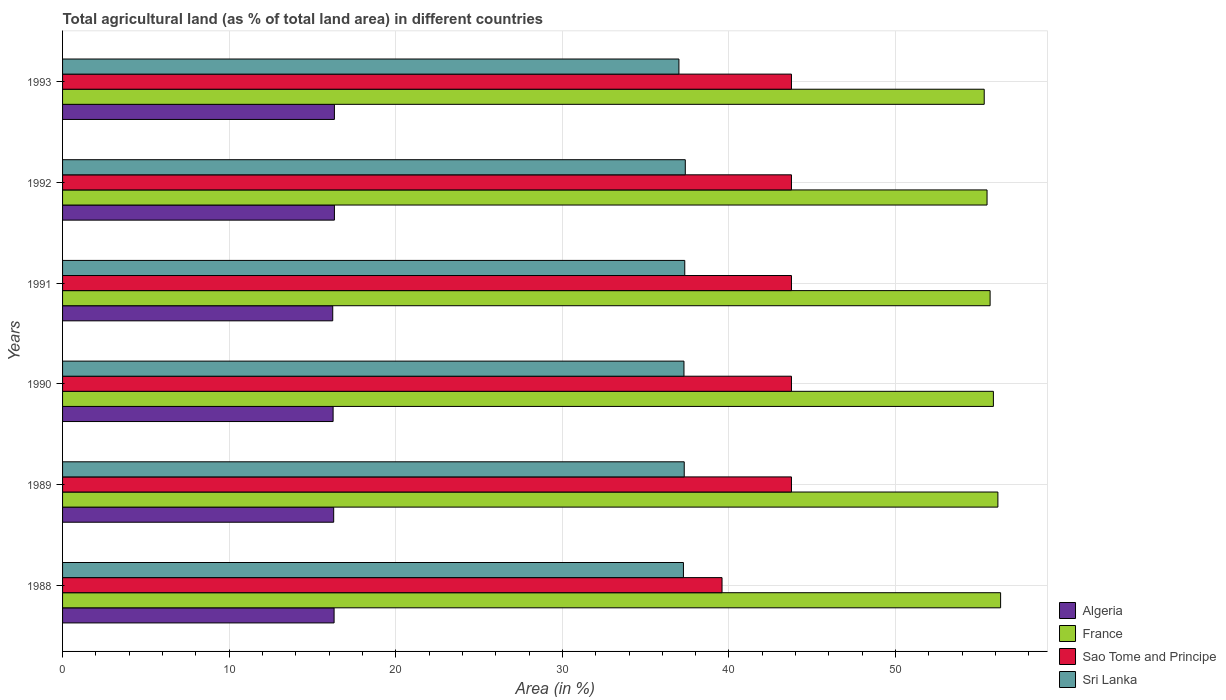How many groups of bars are there?
Offer a very short reply. 6. Are the number of bars on each tick of the Y-axis equal?
Your answer should be compact. Yes. How many bars are there on the 2nd tick from the top?
Offer a very short reply. 4. How many bars are there on the 5th tick from the bottom?
Your answer should be very brief. 4. What is the label of the 6th group of bars from the top?
Provide a succinct answer. 1988. In how many cases, is the number of bars for a given year not equal to the number of legend labels?
Provide a succinct answer. 0. What is the percentage of agricultural land in Algeria in 1989?
Offer a very short reply. 16.27. Across all years, what is the maximum percentage of agricultural land in Sao Tome and Principe?
Provide a succinct answer. 43.75. Across all years, what is the minimum percentage of agricultural land in France?
Ensure brevity in your answer.  55.32. In which year was the percentage of agricultural land in Algeria maximum?
Make the answer very short. 1992. What is the total percentage of agricultural land in Sri Lanka in the graph?
Your response must be concise. 223.6. What is the difference between the percentage of agricultural land in Sao Tome and Principe in 1993 and the percentage of agricultural land in Sri Lanka in 1988?
Provide a short and direct response. 6.48. What is the average percentage of agricultural land in Sao Tome and Principe per year?
Offer a terse response. 43.06. In the year 1991, what is the difference between the percentage of agricultural land in Algeria and percentage of agricultural land in France?
Offer a very short reply. -39.46. What is the ratio of the percentage of agricultural land in Algeria in 1990 to that in 1991?
Your response must be concise. 1. What is the difference between the highest and the second highest percentage of agricultural land in Sri Lanka?
Your answer should be very brief. 0.03. What is the difference between the highest and the lowest percentage of agricultural land in Sao Tome and Principe?
Offer a terse response. 4.17. In how many years, is the percentage of agricultural land in France greater than the average percentage of agricultural land in France taken over all years?
Offer a very short reply. 3. Is the sum of the percentage of agricultural land in Algeria in 1989 and 1991 greater than the maximum percentage of agricultural land in Sri Lanka across all years?
Provide a succinct answer. No. Is it the case that in every year, the sum of the percentage of agricultural land in Sao Tome and Principe and percentage of agricultural land in France is greater than the sum of percentage of agricultural land in Sri Lanka and percentage of agricultural land in Algeria?
Give a very brief answer. No. What does the 4th bar from the top in 1990 represents?
Offer a very short reply. Algeria. What does the 3rd bar from the bottom in 1992 represents?
Your response must be concise. Sao Tome and Principe. Is it the case that in every year, the sum of the percentage of agricultural land in France and percentage of agricultural land in Sri Lanka is greater than the percentage of agricultural land in Algeria?
Give a very brief answer. Yes. Are the values on the major ticks of X-axis written in scientific E-notation?
Offer a very short reply. No. Does the graph contain any zero values?
Your response must be concise. No. How many legend labels are there?
Provide a short and direct response. 4. How are the legend labels stacked?
Ensure brevity in your answer.  Vertical. What is the title of the graph?
Ensure brevity in your answer.  Total agricultural land (as % of total land area) in different countries. What is the label or title of the X-axis?
Make the answer very short. Area (in %). What is the Area (in %) in Algeria in 1988?
Ensure brevity in your answer.  16.3. What is the Area (in %) of France in 1988?
Offer a very short reply. 56.3. What is the Area (in %) of Sao Tome and Principe in 1988?
Ensure brevity in your answer.  39.58. What is the Area (in %) of Sri Lanka in 1988?
Your answer should be very brief. 37.27. What is the Area (in %) in Algeria in 1989?
Your answer should be very brief. 16.27. What is the Area (in %) of France in 1989?
Your answer should be compact. 56.14. What is the Area (in %) in Sao Tome and Principe in 1989?
Make the answer very short. 43.75. What is the Area (in %) of Sri Lanka in 1989?
Keep it short and to the point. 37.31. What is the Area (in %) in Algeria in 1990?
Provide a short and direct response. 16.24. What is the Area (in %) of France in 1990?
Your answer should be very brief. 55.87. What is the Area (in %) of Sao Tome and Principe in 1990?
Your answer should be compact. 43.75. What is the Area (in %) in Sri Lanka in 1990?
Keep it short and to the point. 37.3. What is the Area (in %) in Algeria in 1991?
Offer a terse response. 16.22. What is the Area (in %) of France in 1991?
Keep it short and to the point. 55.67. What is the Area (in %) in Sao Tome and Principe in 1991?
Provide a succinct answer. 43.75. What is the Area (in %) in Sri Lanka in 1991?
Offer a very short reply. 37.35. What is the Area (in %) of Algeria in 1992?
Provide a short and direct response. 16.32. What is the Area (in %) of France in 1992?
Keep it short and to the point. 55.49. What is the Area (in %) in Sao Tome and Principe in 1992?
Offer a very short reply. 43.75. What is the Area (in %) in Sri Lanka in 1992?
Offer a very short reply. 37.38. What is the Area (in %) in Algeria in 1993?
Your answer should be very brief. 16.32. What is the Area (in %) of France in 1993?
Your answer should be compact. 55.32. What is the Area (in %) of Sao Tome and Principe in 1993?
Make the answer very short. 43.75. What is the Area (in %) of Sri Lanka in 1993?
Offer a terse response. 37. Across all years, what is the maximum Area (in %) in Algeria?
Offer a terse response. 16.32. Across all years, what is the maximum Area (in %) in France?
Give a very brief answer. 56.3. Across all years, what is the maximum Area (in %) of Sao Tome and Principe?
Your response must be concise. 43.75. Across all years, what is the maximum Area (in %) of Sri Lanka?
Provide a short and direct response. 37.38. Across all years, what is the minimum Area (in %) of Algeria?
Your answer should be very brief. 16.22. Across all years, what is the minimum Area (in %) of France?
Provide a short and direct response. 55.32. Across all years, what is the minimum Area (in %) of Sao Tome and Principe?
Your response must be concise. 39.58. Across all years, what is the minimum Area (in %) in Sri Lanka?
Your answer should be compact. 37. What is the total Area (in %) of Algeria in the graph?
Keep it short and to the point. 97.66. What is the total Area (in %) in France in the graph?
Your answer should be compact. 334.8. What is the total Area (in %) of Sao Tome and Principe in the graph?
Ensure brevity in your answer.  258.33. What is the total Area (in %) in Sri Lanka in the graph?
Your response must be concise. 223.6. What is the difference between the Area (in %) of Algeria in 1988 and that in 1989?
Ensure brevity in your answer.  0.02. What is the difference between the Area (in %) in France in 1988 and that in 1989?
Provide a succinct answer. 0.16. What is the difference between the Area (in %) in Sao Tome and Principe in 1988 and that in 1989?
Provide a succinct answer. -4.17. What is the difference between the Area (in %) in Sri Lanka in 1988 and that in 1989?
Offer a terse response. -0.05. What is the difference between the Area (in %) of Algeria in 1988 and that in 1990?
Give a very brief answer. 0.06. What is the difference between the Area (in %) in France in 1988 and that in 1990?
Offer a very short reply. 0.43. What is the difference between the Area (in %) in Sao Tome and Principe in 1988 and that in 1990?
Ensure brevity in your answer.  -4.17. What is the difference between the Area (in %) in Sri Lanka in 1988 and that in 1990?
Give a very brief answer. -0.03. What is the difference between the Area (in %) in Algeria in 1988 and that in 1991?
Make the answer very short. 0.08. What is the difference between the Area (in %) of France in 1988 and that in 1991?
Provide a succinct answer. 0.63. What is the difference between the Area (in %) in Sao Tome and Principe in 1988 and that in 1991?
Provide a succinct answer. -4.17. What is the difference between the Area (in %) of Sri Lanka in 1988 and that in 1991?
Your answer should be very brief. -0.08. What is the difference between the Area (in %) of Algeria in 1988 and that in 1992?
Your response must be concise. -0.02. What is the difference between the Area (in %) of France in 1988 and that in 1992?
Offer a very short reply. 0.81. What is the difference between the Area (in %) in Sao Tome and Principe in 1988 and that in 1992?
Offer a very short reply. -4.17. What is the difference between the Area (in %) of Sri Lanka in 1988 and that in 1992?
Ensure brevity in your answer.  -0.11. What is the difference between the Area (in %) in Algeria in 1988 and that in 1993?
Make the answer very short. -0.02. What is the difference between the Area (in %) in France in 1988 and that in 1993?
Provide a succinct answer. 0.98. What is the difference between the Area (in %) in Sao Tome and Principe in 1988 and that in 1993?
Give a very brief answer. -4.17. What is the difference between the Area (in %) of Sri Lanka in 1988 and that in 1993?
Make the answer very short. 0.27. What is the difference between the Area (in %) of Algeria in 1989 and that in 1990?
Ensure brevity in your answer.  0.04. What is the difference between the Area (in %) of France in 1989 and that in 1990?
Keep it short and to the point. 0.27. What is the difference between the Area (in %) in Sao Tome and Principe in 1989 and that in 1990?
Provide a short and direct response. 0. What is the difference between the Area (in %) of Sri Lanka in 1989 and that in 1990?
Your response must be concise. 0.02. What is the difference between the Area (in %) in Algeria in 1989 and that in 1991?
Make the answer very short. 0.06. What is the difference between the Area (in %) of France in 1989 and that in 1991?
Give a very brief answer. 0.47. What is the difference between the Area (in %) in Sao Tome and Principe in 1989 and that in 1991?
Provide a succinct answer. 0. What is the difference between the Area (in %) in Sri Lanka in 1989 and that in 1991?
Offer a terse response. -0.03. What is the difference between the Area (in %) in Algeria in 1989 and that in 1992?
Offer a terse response. -0.04. What is the difference between the Area (in %) of France in 1989 and that in 1992?
Make the answer very short. 0.65. What is the difference between the Area (in %) of Sao Tome and Principe in 1989 and that in 1992?
Ensure brevity in your answer.  0. What is the difference between the Area (in %) in Sri Lanka in 1989 and that in 1992?
Your answer should be compact. -0.06. What is the difference between the Area (in %) in Algeria in 1989 and that in 1993?
Make the answer very short. -0.04. What is the difference between the Area (in %) in France in 1989 and that in 1993?
Offer a very short reply. 0.82. What is the difference between the Area (in %) in Sri Lanka in 1989 and that in 1993?
Your answer should be very brief. 0.32. What is the difference between the Area (in %) of Algeria in 1990 and that in 1991?
Provide a succinct answer. 0.02. What is the difference between the Area (in %) of France in 1990 and that in 1991?
Give a very brief answer. 0.2. What is the difference between the Area (in %) in Sri Lanka in 1990 and that in 1991?
Provide a short and direct response. -0.05. What is the difference between the Area (in %) in Algeria in 1990 and that in 1992?
Your answer should be compact. -0.08. What is the difference between the Area (in %) of France in 1990 and that in 1992?
Make the answer very short. 0.38. What is the difference between the Area (in %) of Sao Tome and Principe in 1990 and that in 1992?
Your response must be concise. 0. What is the difference between the Area (in %) of Sri Lanka in 1990 and that in 1992?
Offer a very short reply. -0.08. What is the difference between the Area (in %) of Algeria in 1990 and that in 1993?
Give a very brief answer. -0.08. What is the difference between the Area (in %) in France in 1990 and that in 1993?
Give a very brief answer. 0.55. What is the difference between the Area (in %) of Sri Lanka in 1990 and that in 1993?
Your answer should be compact. 0.3. What is the difference between the Area (in %) in Algeria in 1991 and that in 1992?
Keep it short and to the point. -0.1. What is the difference between the Area (in %) of France in 1991 and that in 1992?
Offer a very short reply. 0.18. What is the difference between the Area (in %) of Sao Tome and Principe in 1991 and that in 1992?
Your answer should be compact. 0. What is the difference between the Area (in %) in Sri Lanka in 1991 and that in 1992?
Your answer should be compact. -0.03. What is the difference between the Area (in %) in Algeria in 1991 and that in 1993?
Provide a succinct answer. -0.1. What is the difference between the Area (in %) in France in 1991 and that in 1993?
Provide a succinct answer. 0.35. What is the difference between the Area (in %) of Sri Lanka in 1991 and that in 1993?
Make the answer very short. 0.35. What is the difference between the Area (in %) in Algeria in 1992 and that in 1993?
Offer a terse response. 0. What is the difference between the Area (in %) of France in 1992 and that in 1993?
Offer a very short reply. 0.17. What is the difference between the Area (in %) of Sri Lanka in 1992 and that in 1993?
Offer a very short reply. 0.38. What is the difference between the Area (in %) in Algeria in 1988 and the Area (in %) in France in 1989?
Provide a short and direct response. -39.84. What is the difference between the Area (in %) of Algeria in 1988 and the Area (in %) of Sao Tome and Principe in 1989?
Give a very brief answer. -27.45. What is the difference between the Area (in %) of Algeria in 1988 and the Area (in %) of Sri Lanka in 1989?
Your answer should be very brief. -21.02. What is the difference between the Area (in %) in France in 1988 and the Area (in %) in Sao Tome and Principe in 1989?
Your answer should be compact. 12.55. What is the difference between the Area (in %) of France in 1988 and the Area (in %) of Sri Lanka in 1989?
Provide a short and direct response. 18.99. What is the difference between the Area (in %) in Sao Tome and Principe in 1988 and the Area (in %) in Sri Lanka in 1989?
Ensure brevity in your answer.  2.27. What is the difference between the Area (in %) in Algeria in 1988 and the Area (in %) in France in 1990?
Ensure brevity in your answer.  -39.57. What is the difference between the Area (in %) in Algeria in 1988 and the Area (in %) in Sao Tome and Principe in 1990?
Your response must be concise. -27.45. What is the difference between the Area (in %) in Algeria in 1988 and the Area (in %) in Sri Lanka in 1990?
Your answer should be compact. -21. What is the difference between the Area (in %) of France in 1988 and the Area (in %) of Sao Tome and Principe in 1990?
Offer a very short reply. 12.55. What is the difference between the Area (in %) in France in 1988 and the Area (in %) in Sri Lanka in 1990?
Offer a terse response. 19. What is the difference between the Area (in %) of Sao Tome and Principe in 1988 and the Area (in %) of Sri Lanka in 1990?
Provide a succinct answer. 2.28. What is the difference between the Area (in %) of Algeria in 1988 and the Area (in %) of France in 1991?
Make the answer very short. -39.38. What is the difference between the Area (in %) of Algeria in 1988 and the Area (in %) of Sao Tome and Principe in 1991?
Offer a very short reply. -27.45. What is the difference between the Area (in %) in Algeria in 1988 and the Area (in %) in Sri Lanka in 1991?
Your answer should be very brief. -21.05. What is the difference between the Area (in %) in France in 1988 and the Area (in %) in Sao Tome and Principe in 1991?
Your response must be concise. 12.55. What is the difference between the Area (in %) in France in 1988 and the Area (in %) in Sri Lanka in 1991?
Your response must be concise. 18.96. What is the difference between the Area (in %) of Sao Tome and Principe in 1988 and the Area (in %) of Sri Lanka in 1991?
Ensure brevity in your answer.  2.24. What is the difference between the Area (in %) in Algeria in 1988 and the Area (in %) in France in 1992?
Your answer should be compact. -39.19. What is the difference between the Area (in %) of Algeria in 1988 and the Area (in %) of Sao Tome and Principe in 1992?
Your answer should be very brief. -27.45. What is the difference between the Area (in %) in Algeria in 1988 and the Area (in %) in Sri Lanka in 1992?
Ensure brevity in your answer.  -21.08. What is the difference between the Area (in %) in France in 1988 and the Area (in %) in Sao Tome and Principe in 1992?
Your answer should be very brief. 12.55. What is the difference between the Area (in %) of France in 1988 and the Area (in %) of Sri Lanka in 1992?
Offer a very short reply. 18.93. What is the difference between the Area (in %) of Sao Tome and Principe in 1988 and the Area (in %) of Sri Lanka in 1992?
Your response must be concise. 2.2. What is the difference between the Area (in %) of Algeria in 1988 and the Area (in %) of France in 1993?
Keep it short and to the point. -39.02. What is the difference between the Area (in %) in Algeria in 1988 and the Area (in %) in Sao Tome and Principe in 1993?
Offer a terse response. -27.45. What is the difference between the Area (in %) in Algeria in 1988 and the Area (in %) in Sri Lanka in 1993?
Your answer should be compact. -20.7. What is the difference between the Area (in %) in France in 1988 and the Area (in %) in Sao Tome and Principe in 1993?
Your response must be concise. 12.55. What is the difference between the Area (in %) in France in 1988 and the Area (in %) in Sri Lanka in 1993?
Ensure brevity in your answer.  19.31. What is the difference between the Area (in %) of Sao Tome and Principe in 1988 and the Area (in %) of Sri Lanka in 1993?
Your answer should be very brief. 2.59. What is the difference between the Area (in %) of Algeria in 1989 and the Area (in %) of France in 1990?
Provide a short and direct response. -39.6. What is the difference between the Area (in %) in Algeria in 1989 and the Area (in %) in Sao Tome and Principe in 1990?
Offer a very short reply. -27.48. What is the difference between the Area (in %) of Algeria in 1989 and the Area (in %) of Sri Lanka in 1990?
Keep it short and to the point. -21.02. What is the difference between the Area (in %) of France in 1989 and the Area (in %) of Sao Tome and Principe in 1990?
Make the answer very short. 12.39. What is the difference between the Area (in %) in France in 1989 and the Area (in %) in Sri Lanka in 1990?
Provide a short and direct response. 18.84. What is the difference between the Area (in %) in Sao Tome and Principe in 1989 and the Area (in %) in Sri Lanka in 1990?
Provide a succinct answer. 6.45. What is the difference between the Area (in %) in Algeria in 1989 and the Area (in %) in France in 1991?
Provide a short and direct response. -39.4. What is the difference between the Area (in %) of Algeria in 1989 and the Area (in %) of Sao Tome and Principe in 1991?
Offer a very short reply. -27.48. What is the difference between the Area (in %) in Algeria in 1989 and the Area (in %) in Sri Lanka in 1991?
Keep it short and to the point. -21.07. What is the difference between the Area (in %) of France in 1989 and the Area (in %) of Sao Tome and Principe in 1991?
Your answer should be compact. 12.39. What is the difference between the Area (in %) in France in 1989 and the Area (in %) in Sri Lanka in 1991?
Offer a terse response. 18.79. What is the difference between the Area (in %) of Sao Tome and Principe in 1989 and the Area (in %) of Sri Lanka in 1991?
Your answer should be very brief. 6.4. What is the difference between the Area (in %) in Algeria in 1989 and the Area (in %) in France in 1992?
Make the answer very short. -39.22. What is the difference between the Area (in %) in Algeria in 1989 and the Area (in %) in Sao Tome and Principe in 1992?
Keep it short and to the point. -27.48. What is the difference between the Area (in %) of Algeria in 1989 and the Area (in %) of Sri Lanka in 1992?
Make the answer very short. -21.1. What is the difference between the Area (in %) in France in 1989 and the Area (in %) in Sao Tome and Principe in 1992?
Make the answer very short. 12.39. What is the difference between the Area (in %) in France in 1989 and the Area (in %) in Sri Lanka in 1992?
Your answer should be very brief. 18.76. What is the difference between the Area (in %) in Sao Tome and Principe in 1989 and the Area (in %) in Sri Lanka in 1992?
Keep it short and to the point. 6.37. What is the difference between the Area (in %) of Algeria in 1989 and the Area (in %) of France in 1993?
Keep it short and to the point. -39.05. What is the difference between the Area (in %) of Algeria in 1989 and the Area (in %) of Sao Tome and Principe in 1993?
Offer a terse response. -27.48. What is the difference between the Area (in %) of Algeria in 1989 and the Area (in %) of Sri Lanka in 1993?
Make the answer very short. -20.72. What is the difference between the Area (in %) in France in 1989 and the Area (in %) in Sao Tome and Principe in 1993?
Your response must be concise. 12.39. What is the difference between the Area (in %) in France in 1989 and the Area (in %) in Sri Lanka in 1993?
Your response must be concise. 19.15. What is the difference between the Area (in %) of Sao Tome and Principe in 1989 and the Area (in %) of Sri Lanka in 1993?
Give a very brief answer. 6.75. What is the difference between the Area (in %) in Algeria in 1990 and the Area (in %) in France in 1991?
Give a very brief answer. -39.43. What is the difference between the Area (in %) of Algeria in 1990 and the Area (in %) of Sao Tome and Principe in 1991?
Offer a very short reply. -27.51. What is the difference between the Area (in %) of Algeria in 1990 and the Area (in %) of Sri Lanka in 1991?
Your answer should be very brief. -21.11. What is the difference between the Area (in %) in France in 1990 and the Area (in %) in Sao Tome and Principe in 1991?
Keep it short and to the point. 12.12. What is the difference between the Area (in %) in France in 1990 and the Area (in %) in Sri Lanka in 1991?
Your answer should be very brief. 18.52. What is the difference between the Area (in %) in Sao Tome and Principe in 1990 and the Area (in %) in Sri Lanka in 1991?
Ensure brevity in your answer.  6.4. What is the difference between the Area (in %) of Algeria in 1990 and the Area (in %) of France in 1992?
Offer a terse response. -39.25. What is the difference between the Area (in %) of Algeria in 1990 and the Area (in %) of Sao Tome and Principe in 1992?
Provide a succinct answer. -27.51. What is the difference between the Area (in %) in Algeria in 1990 and the Area (in %) in Sri Lanka in 1992?
Keep it short and to the point. -21.14. What is the difference between the Area (in %) of France in 1990 and the Area (in %) of Sao Tome and Principe in 1992?
Ensure brevity in your answer.  12.12. What is the difference between the Area (in %) of France in 1990 and the Area (in %) of Sri Lanka in 1992?
Provide a short and direct response. 18.49. What is the difference between the Area (in %) in Sao Tome and Principe in 1990 and the Area (in %) in Sri Lanka in 1992?
Provide a succinct answer. 6.37. What is the difference between the Area (in %) of Algeria in 1990 and the Area (in %) of France in 1993?
Provide a succinct answer. -39.08. What is the difference between the Area (in %) in Algeria in 1990 and the Area (in %) in Sao Tome and Principe in 1993?
Your response must be concise. -27.51. What is the difference between the Area (in %) in Algeria in 1990 and the Area (in %) in Sri Lanka in 1993?
Your answer should be very brief. -20.76. What is the difference between the Area (in %) in France in 1990 and the Area (in %) in Sao Tome and Principe in 1993?
Offer a terse response. 12.12. What is the difference between the Area (in %) of France in 1990 and the Area (in %) of Sri Lanka in 1993?
Make the answer very short. 18.87. What is the difference between the Area (in %) in Sao Tome and Principe in 1990 and the Area (in %) in Sri Lanka in 1993?
Give a very brief answer. 6.75. What is the difference between the Area (in %) in Algeria in 1991 and the Area (in %) in France in 1992?
Provide a succinct answer. -39.27. What is the difference between the Area (in %) of Algeria in 1991 and the Area (in %) of Sao Tome and Principe in 1992?
Provide a succinct answer. -27.53. What is the difference between the Area (in %) in Algeria in 1991 and the Area (in %) in Sri Lanka in 1992?
Your response must be concise. -21.16. What is the difference between the Area (in %) of France in 1991 and the Area (in %) of Sao Tome and Principe in 1992?
Your response must be concise. 11.92. What is the difference between the Area (in %) of France in 1991 and the Area (in %) of Sri Lanka in 1992?
Provide a succinct answer. 18.3. What is the difference between the Area (in %) in Sao Tome and Principe in 1991 and the Area (in %) in Sri Lanka in 1992?
Offer a terse response. 6.37. What is the difference between the Area (in %) of Algeria in 1991 and the Area (in %) of France in 1993?
Your answer should be very brief. -39.1. What is the difference between the Area (in %) of Algeria in 1991 and the Area (in %) of Sao Tome and Principe in 1993?
Provide a succinct answer. -27.53. What is the difference between the Area (in %) in Algeria in 1991 and the Area (in %) in Sri Lanka in 1993?
Your response must be concise. -20.78. What is the difference between the Area (in %) of France in 1991 and the Area (in %) of Sao Tome and Principe in 1993?
Make the answer very short. 11.92. What is the difference between the Area (in %) of France in 1991 and the Area (in %) of Sri Lanka in 1993?
Keep it short and to the point. 18.68. What is the difference between the Area (in %) of Sao Tome and Principe in 1991 and the Area (in %) of Sri Lanka in 1993?
Your response must be concise. 6.75. What is the difference between the Area (in %) of Algeria in 1992 and the Area (in %) of France in 1993?
Your answer should be compact. -39. What is the difference between the Area (in %) in Algeria in 1992 and the Area (in %) in Sao Tome and Principe in 1993?
Offer a terse response. -27.43. What is the difference between the Area (in %) in Algeria in 1992 and the Area (in %) in Sri Lanka in 1993?
Ensure brevity in your answer.  -20.68. What is the difference between the Area (in %) of France in 1992 and the Area (in %) of Sao Tome and Principe in 1993?
Your answer should be very brief. 11.74. What is the difference between the Area (in %) of France in 1992 and the Area (in %) of Sri Lanka in 1993?
Keep it short and to the point. 18.49. What is the difference between the Area (in %) of Sao Tome and Principe in 1992 and the Area (in %) of Sri Lanka in 1993?
Provide a succinct answer. 6.75. What is the average Area (in %) of Algeria per year?
Make the answer very short. 16.28. What is the average Area (in %) in France per year?
Give a very brief answer. 55.8. What is the average Area (in %) of Sao Tome and Principe per year?
Provide a short and direct response. 43.06. What is the average Area (in %) in Sri Lanka per year?
Keep it short and to the point. 37.27. In the year 1988, what is the difference between the Area (in %) in Algeria and Area (in %) in France?
Your answer should be very brief. -40.01. In the year 1988, what is the difference between the Area (in %) of Algeria and Area (in %) of Sao Tome and Principe?
Ensure brevity in your answer.  -23.29. In the year 1988, what is the difference between the Area (in %) of Algeria and Area (in %) of Sri Lanka?
Your response must be concise. -20.97. In the year 1988, what is the difference between the Area (in %) in France and Area (in %) in Sao Tome and Principe?
Provide a succinct answer. 16.72. In the year 1988, what is the difference between the Area (in %) of France and Area (in %) of Sri Lanka?
Offer a terse response. 19.04. In the year 1988, what is the difference between the Area (in %) in Sao Tome and Principe and Area (in %) in Sri Lanka?
Offer a terse response. 2.32. In the year 1989, what is the difference between the Area (in %) in Algeria and Area (in %) in France?
Offer a very short reply. -39.87. In the year 1989, what is the difference between the Area (in %) of Algeria and Area (in %) of Sao Tome and Principe?
Keep it short and to the point. -27.48. In the year 1989, what is the difference between the Area (in %) of Algeria and Area (in %) of Sri Lanka?
Offer a terse response. -21.04. In the year 1989, what is the difference between the Area (in %) in France and Area (in %) in Sao Tome and Principe?
Give a very brief answer. 12.39. In the year 1989, what is the difference between the Area (in %) in France and Area (in %) in Sri Lanka?
Your answer should be very brief. 18.83. In the year 1989, what is the difference between the Area (in %) of Sao Tome and Principe and Area (in %) of Sri Lanka?
Give a very brief answer. 6.44. In the year 1990, what is the difference between the Area (in %) of Algeria and Area (in %) of France?
Your answer should be very brief. -39.63. In the year 1990, what is the difference between the Area (in %) in Algeria and Area (in %) in Sao Tome and Principe?
Provide a short and direct response. -27.51. In the year 1990, what is the difference between the Area (in %) of Algeria and Area (in %) of Sri Lanka?
Keep it short and to the point. -21.06. In the year 1990, what is the difference between the Area (in %) of France and Area (in %) of Sao Tome and Principe?
Give a very brief answer. 12.12. In the year 1990, what is the difference between the Area (in %) in France and Area (in %) in Sri Lanka?
Provide a short and direct response. 18.57. In the year 1990, what is the difference between the Area (in %) of Sao Tome and Principe and Area (in %) of Sri Lanka?
Provide a succinct answer. 6.45. In the year 1991, what is the difference between the Area (in %) of Algeria and Area (in %) of France?
Provide a succinct answer. -39.46. In the year 1991, what is the difference between the Area (in %) in Algeria and Area (in %) in Sao Tome and Principe?
Provide a short and direct response. -27.53. In the year 1991, what is the difference between the Area (in %) in Algeria and Area (in %) in Sri Lanka?
Your response must be concise. -21.13. In the year 1991, what is the difference between the Area (in %) in France and Area (in %) in Sao Tome and Principe?
Keep it short and to the point. 11.92. In the year 1991, what is the difference between the Area (in %) of France and Area (in %) of Sri Lanka?
Give a very brief answer. 18.33. In the year 1991, what is the difference between the Area (in %) in Sao Tome and Principe and Area (in %) in Sri Lanka?
Offer a terse response. 6.4. In the year 1992, what is the difference between the Area (in %) of Algeria and Area (in %) of France?
Provide a short and direct response. -39.17. In the year 1992, what is the difference between the Area (in %) of Algeria and Area (in %) of Sao Tome and Principe?
Offer a terse response. -27.43. In the year 1992, what is the difference between the Area (in %) in Algeria and Area (in %) in Sri Lanka?
Your response must be concise. -21.06. In the year 1992, what is the difference between the Area (in %) in France and Area (in %) in Sao Tome and Principe?
Make the answer very short. 11.74. In the year 1992, what is the difference between the Area (in %) of France and Area (in %) of Sri Lanka?
Ensure brevity in your answer.  18.11. In the year 1992, what is the difference between the Area (in %) of Sao Tome and Principe and Area (in %) of Sri Lanka?
Ensure brevity in your answer.  6.37. In the year 1993, what is the difference between the Area (in %) of Algeria and Area (in %) of France?
Ensure brevity in your answer.  -39. In the year 1993, what is the difference between the Area (in %) of Algeria and Area (in %) of Sao Tome and Principe?
Your response must be concise. -27.43. In the year 1993, what is the difference between the Area (in %) in Algeria and Area (in %) in Sri Lanka?
Keep it short and to the point. -20.68. In the year 1993, what is the difference between the Area (in %) of France and Area (in %) of Sao Tome and Principe?
Make the answer very short. 11.57. In the year 1993, what is the difference between the Area (in %) in France and Area (in %) in Sri Lanka?
Give a very brief answer. 18.32. In the year 1993, what is the difference between the Area (in %) of Sao Tome and Principe and Area (in %) of Sri Lanka?
Offer a very short reply. 6.75. What is the ratio of the Area (in %) in France in 1988 to that in 1989?
Provide a succinct answer. 1. What is the ratio of the Area (in %) of Sao Tome and Principe in 1988 to that in 1989?
Offer a very short reply. 0.9. What is the ratio of the Area (in %) of Sri Lanka in 1988 to that in 1989?
Make the answer very short. 1. What is the ratio of the Area (in %) in Algeria in 1988 to that in 1990?
Give a very brief answer. 1. What is the ratio of the Area (in %) of Sao Tome and Principe in 1988 to that in 1990?
Offer a terse response. 0.9. What is the ratio of the Area (in %) of Algeria in 1988 to that in 1991?
Give a very brief answer. 1. What is the ratio of the Area (in %) in France in 1988 to that in 1991?
Make the answer very short. 1.01. What is the ratio of the Area (in %) of Sao Tome and Principe in 1988 to that in 1991?
Provide a succinct answer. 0.9. What is the ratio of the Area (in %) in France in 1988 to that in 1992?
Offer a terse response. 1.01. What is the ratio of the Area (in %) of Sao Tome and Principe in 1988 to that in 1992?
Ensure brevity in your answer.  0.9. What is the ratio of the Area (in %) in Sri Lanka in 1988 to that in 1992?
Your answer should be very brief. 1. What is the ratio of the Area (in %) in Algeria in 1988 to that in 1993?
Provide a succinct answer. 1. What is the ratio of the Area (in %) of France in 1988 to that in 1993?
Offer a very short reply. 1.02. What is the ratio of the Area (in %) in Sao Tome and Principe in 1988 to that in 1993?
Keep it short and to the point. 0.9. What is the ratio of the Area (in %) in Sri Lanka in 1988 to that in 1993?
Make the answer very short. 1.01. What is the ratio of the Area (in %) in Algeria in 1989 to that in 1990?
Make the answer very short. 1. What is the ratio of the Area (in %) in France in 1989 to that in 1990?
Give a very brief answer. 1. What is the ratio of the Area (in %) of Sao Tome and Principe in 1989 to that in 1990?
Offer a very short reply. 1. What is the ratio of the Area (in %) of Algeria in 1989 to that in 1991?
Your response must be concise. 1. What is the ratio of the Area (in %) of France in 1989 to that in 1991?
Make the answer very short. 1.01. What is the ratio of the Area (in %) of Sao Tome and Principe in 1989 to that in 1991?
Offer a very short reply. 1. What is the ratio of the Area (in %) in Algeria in 1989 to that in 1992?
Provide a succinct answer. 1. What is the ratio of the Area (in %) of France in 1989 to that in 1992?
Offer a very short reply. 1.01. What is the ratio of the Area (in %) in Algeria in 1989 to that in 1993?
Your response must be concise. 1. What is the ratio of the Area (in %) of France in 1989 to that in 1993?
Ensure brevity in your answer.  1.01. What is the ratio of the Area (in %) in Sao Tome and Principe in 1989 to that in 1993?
Offer a very short reply. 1. What is the ratio of the Area (in %) of Sri Lanka in 1989 to that in 1993?
Offer a terse response. 1.01. What is the ratio of the Area (in %) of Algeria in 1990 to that in 1991?
Make the answer very short. 1. What is the ratio of the Area (in %) in Sao Tome and Principe in 1990 to that in 1991?
Provide a succinct answer. 1. What is the ratio of the Area (in %) of Sri Lanka in 1990 to that in 1992?
Ensure brevity in your answer.  1. What is the ratio of the Area (in %) in Algeria in 1990 to that in 1993?
Offer a very short reply. 1. What is the ratio of the Area (in %) in France in 1990 to that in 1993?
Make the answer very short. 1.01. What is the ratio of the Area (in %) of Sao Tome and Principe in 1990 to that in 1993?
Make the answer very short. 1. What is the ratio of the Area (in %) in Sri Lanka in 1990 to that in 1993?
Ensure brevity in your answer.  1.01. What is the ratio of the Area (in %) of France in 1991 to that in 1992?
Give a very brief answer. 1. What is the ratio of the Area (in %) in Sri Lanka in 1991 to that in 1992?
Provide a short and direct response. 1. What is the ratio of the Area (in %) of Algeria in 1991 to that in 1993?
Your answer should be very brief. 0.99. What is the ratio of the Area (in %) of France in 1991 to that in 1993?
Give a very brief answer. 1.01. What is the ratio of the Area (in %) of Sao Tome and Principe in 1991 to that in 1993?
Your response must be concise. 1. What is the ratio of the Area (in %) of Sri Lanka in 1991 to that in 1993?
Your answer should be compact. 1.01. What is the ratio of the Area (in %) of Algeria in 1992 to that in 1993?
Your response must be concise. 1. What is the ratio of the Area (in %) of Sri Lanka in 1992 to that in 1993?
Your response must be concise. 1.01. What is the difference between the highest and the second highest Area (in %) of Algeria?
Keep it short and to the point. 0. What is the difference between the highest and the second highest Area (in %) in France?
Give a very brief answer. 0.16. What is the difference between the highest and the second highest Area (in %) in Sri Lanka?
Provide a succinct answer. 0.03. What is the difference between the highest and the lowest Area (in %) of Algeria?
Offer a very short reply. 0.1. What is the difference between the highest and the lowest Area (in %) in France?
Offer a very short reply. 0.98. What is the difference between the highest and the lowest Area (in %) in Sao Tome and Principe?
Give a very brief answer. 4.17. What is the difference between the highest and the lowest Area (in %) of Sri Lanka?
Provide a short and direct response. 0.38. 